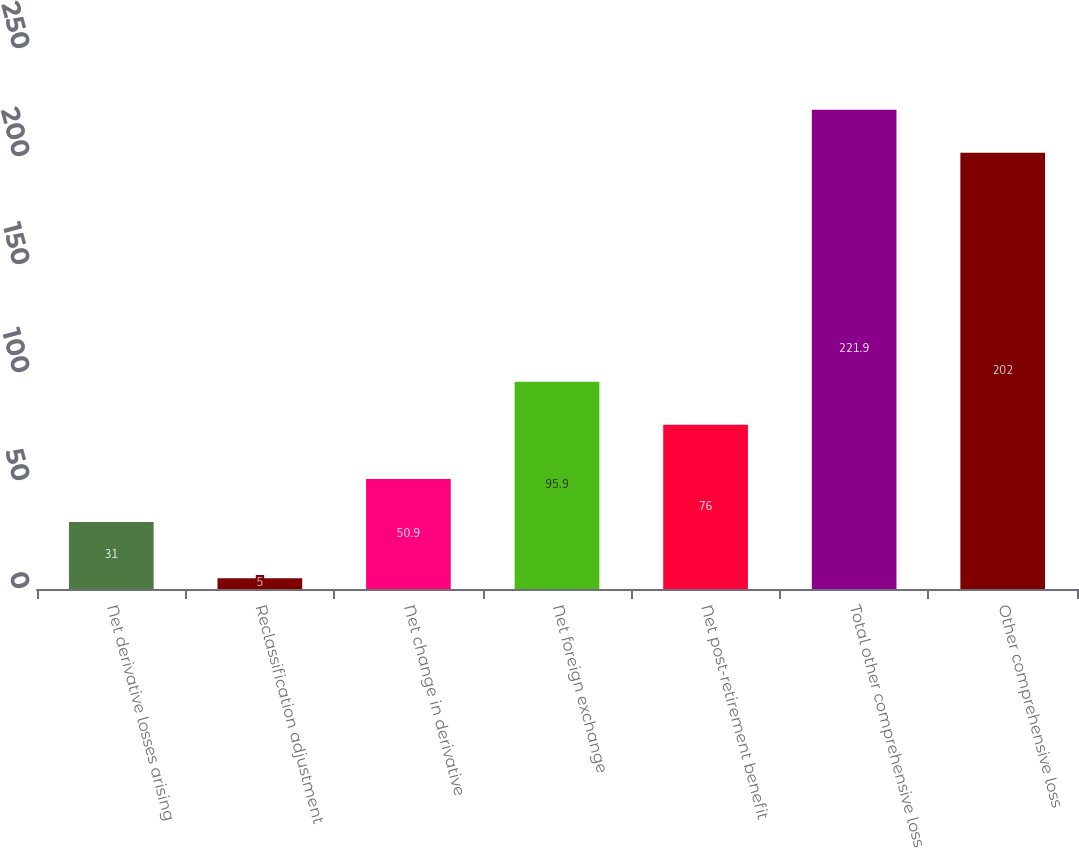Convert chart to OTSL. <chart><loc_0><loc_0><loc_500><loc_500><bar_chart><fcel>Net derivative losses arising<fcel>Reclassification adjustment<fcel>Net change in derivative<fcel>Net foreign exchange<fcel>Net post-retirement benefit<fcel>Total other comprehensive loss<fcel>Other comprehensive loss<nl><fcel>31<fcel>5<fcel>50.9<fcel>95.9<fcel>76<fcel>221.9<fcel>202<nl></chart> 